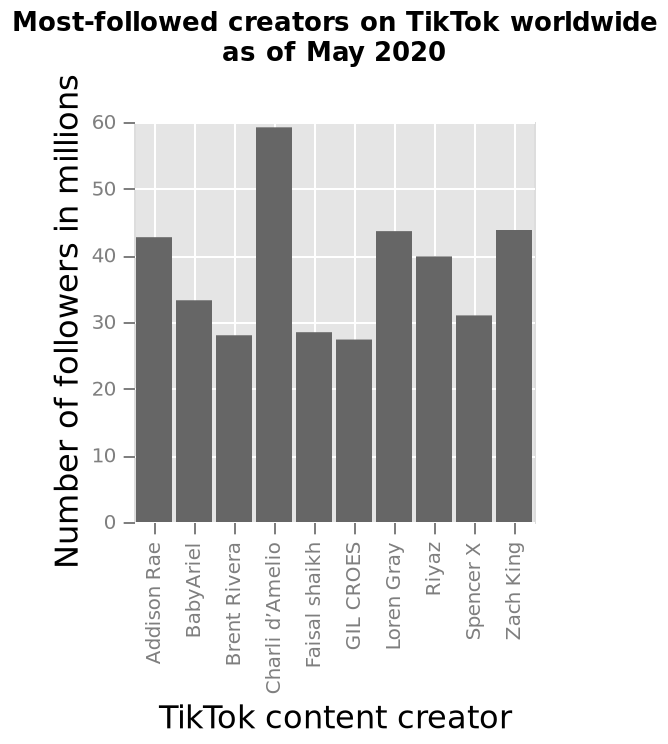<image>
Who are tied in second place for followers? The three people Who has the greatest number of followers?  Charli please describe the details of the chart This bar diagram is labeled Most-followed creators on TikTok worldwide as of May 2020. The y-axis plots Number of followers in millions while the x-axis measures TikTok content creator. Who has the least followers?  Gil Offer a thorough analysis of the image. Charli has the greatest number of followers: nearly 60 millionGil has the least followers. Three come closely tied in second place. 